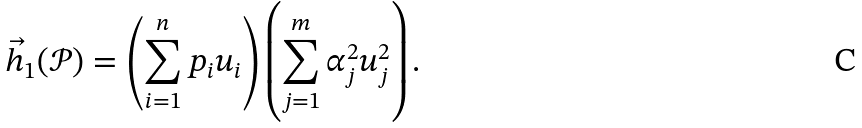<formula> <loc_0><loc_0><loc_500><loc_500>\vec { h } _ { 1 } ( { \mathcal { P } } ) = \left ( \sum _ { i = 1 } ^ { n } p _ { i } u _ { i } \right ) \left ( \sum _ { j = 1 } ^ { m } \alpha _ { j } ^ { 2 } u _ { j } ^ { 2 } \right ) .</formula> 